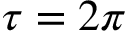Convert formula to latex. <formula><loc_0><loc_0><loc_500><loc_500>\tau = 2 \pi</formula> 